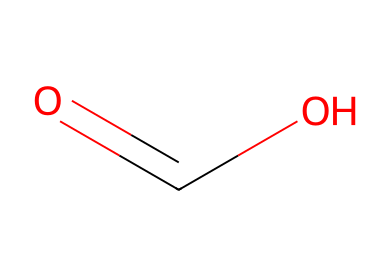What is the molecular formula of formic acid? The SMILES representation (O=C(O)) indicates that there are one carbon atom (C), two oxygen atoms (O), and two hydrogen atoms (H) in the molecule. Therefore, the molecular formula can be deduced as HCOOH.
Answer: HCOOH How many hydrogen atoms are present in formic acid? Based on the structural representation, there are two hydrogen atoms indicated alongside one carbon and two oxygen atoms.
Answer: 2 Which type of bonding is primarily present in formic acid? In the provided structure, the carboxylic functional group (C(=O)OH) showcases both single (C-H and C-O) and double (C=O) bonding, with covalent bonds dominating the chemical structure.
Answer: covalent What functional group is represented in formic acid? The structure clearly reveals a carboxylic acid functional group (–COOH), which is characteristic of formic acid. This group is responsible for its acidic properties.
Answer: carboxylic acid Is formic acid an aliphatic compound? The structure contains no aromatic rings and consists of carbon and hydrogen atoms arranged in a linear or branched form, qualifying it as an aliphatic compound.
Answer: yes How many total atoms are in formic acid? Analyzing the structure, we sum one carbon atom, two hydrogen atoms, and two oxygen atoms, giving a total of five atoms.
Answer: 5 What is the significance of the carboxylic acid functional group in formic acid? The carboxylic acid group (–COOH) is critical as it endows the molecule with acidic properties and its potential reactivity as a fuel source produced through synthetic photosynthesis.
Answer: acidity and reactivity 